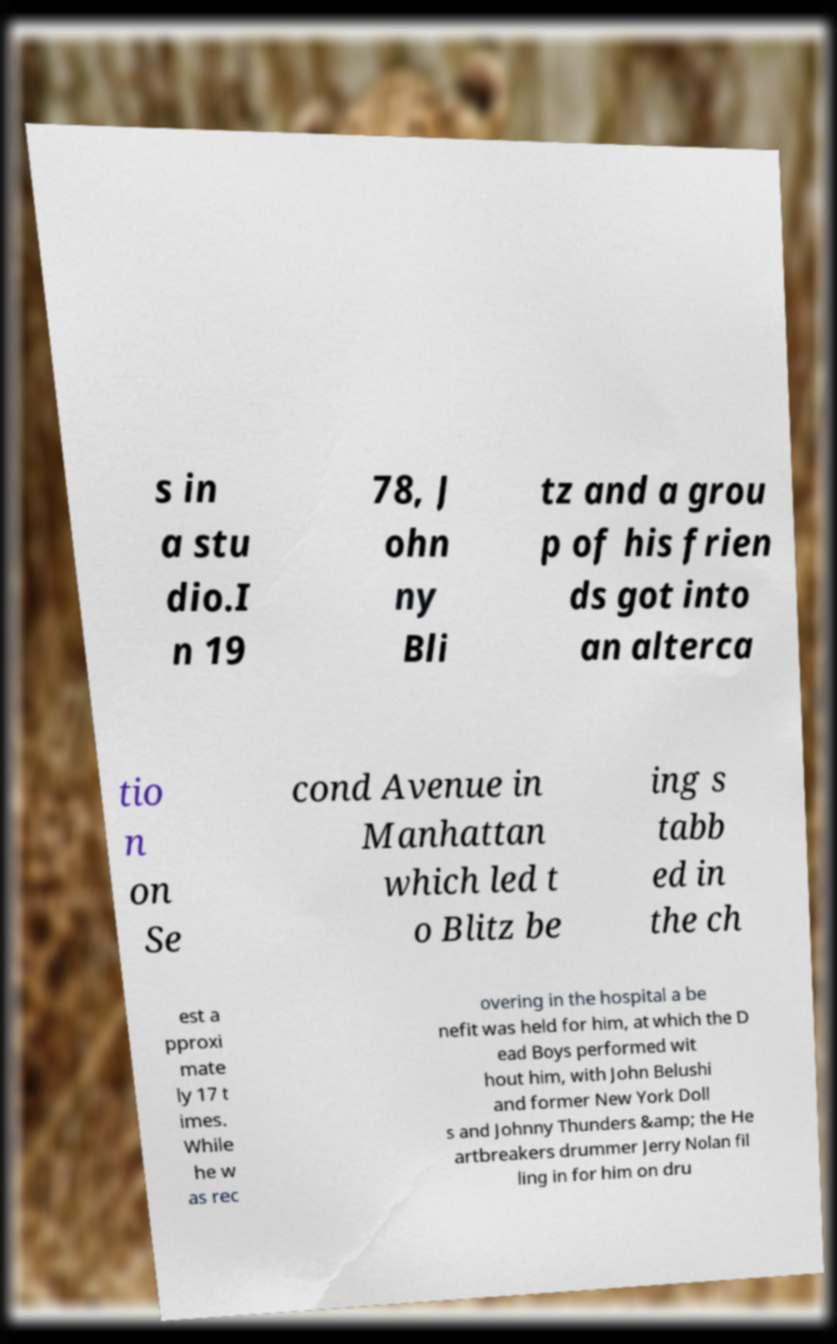I need the written content from this picture converted into text. Can you do that? s in a stu dio.I n 19 78, J ohn ny Bli tz and a grou p of his frien ds got into an alterca tio n on Se cond Avenue in Manhattan which led t o Blitz be ing s tabb ed in the ch est a pproxi mate ly 17 t imes. While he w as rec overing in the hospital a be nefit was held for him, at which the D ead Boys performed wit hout him, with John Belushi and former New York Doll s and Johnny Thunders &amp; the He artbreakers drummer Jerry Nolan fil ling in for him on dru 